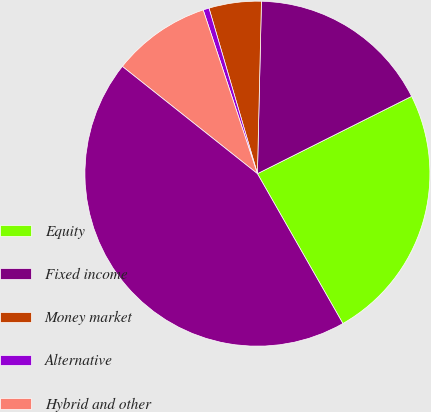<chart> <loc_0><loc_0><loc_500><loc_500><pie_chart><fcel>Equity<fcel>Fixed income<fcel>Money market<fcel>Alternative<fcel>Hybrid and other<fcel>Total managed assets<nl><fcel>24.15%<fcel>17.23%<fcel>4.9%<fcel>0.56%<fcel>9.23%<fcel>43.93%<nl></chart> 